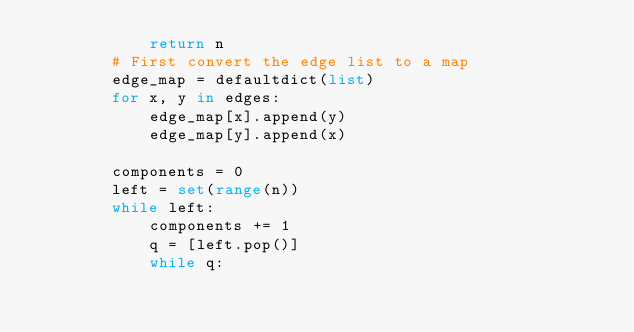<code> <loc_0><loc_0><loc_500><loc_500><_Python_>            return n
        # First convert the edge list to a map
        edge_map = defaultdict(list)
        for x, y in edges:
            edge_map[x].append(y)
            edge_map[y].append(x)

        components = 0
        left = set(range(n))
        while left:
            components += 1
            q = [left.pop()]
            while q:</code> 